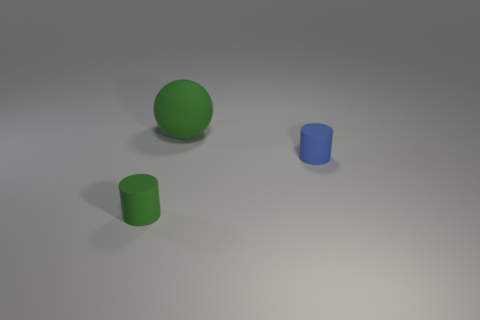Add 3 gray cylinders. How many objects exist? 6 Subtract all cylinders. How many objects are left? 1 Subtract all small green cylinders. Subtract all green rubber cylinders. How many objects are left? 1 Add 2 green matte things. How many green matte things are left? 4 Add 3 blue matte objects. How many blue matte objects exist? 4 Subtract 0 purple spheres. How many objects are left? 3 